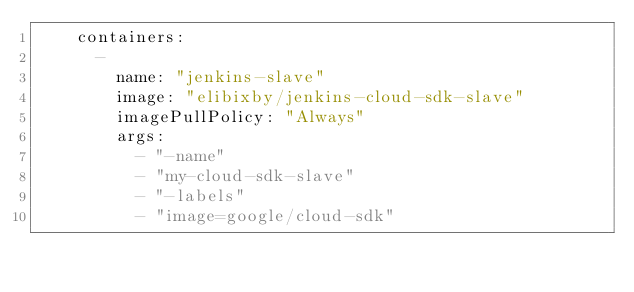<code> <loc_0><loc_0><loc_500><loc_500><_YAML_>    containers: 
      - 
        name: "jenkins-slave"
        image: "elibixby/jenkins-cloud-sdk-slave"
        imagePullPolicy: "Always"
        args: 
          - "-name"
          - "my-cloud-sdk-slave"
          - "-labels"
          - "image=google/cloud-sdk"

</code> 